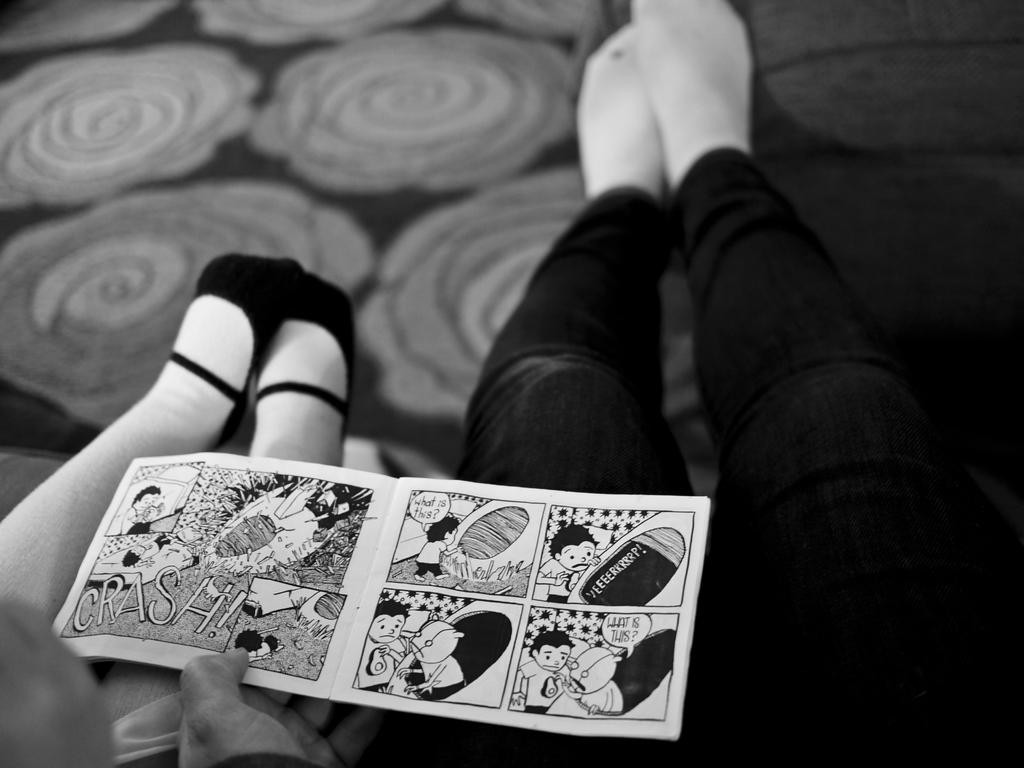What can be seen in the center of the image? There are legs of persons in the center of the image. What is a person at the bottom of the image holding? A card is being held by a person at the bottom of the image. What is the setting of the image? The background of the image includes a floor. What type of cellar is visible in the image? There is no cellar present in the image. Can you describe the spot where the person is standing in the image? The provided facts do not mention a specific spot where the person is standing, so we cannot describe it. 